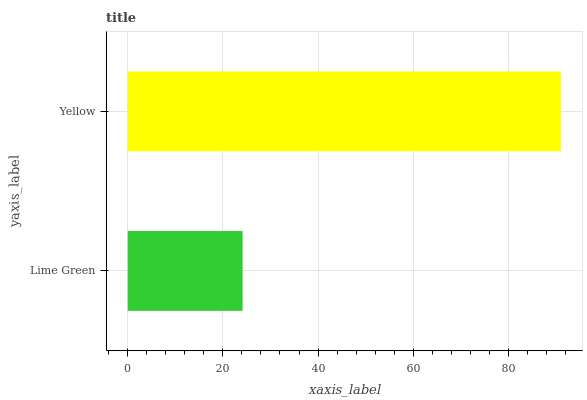Is Lime Green the minimum?
Answer yes or no. Yes. Is Yellow the maximum?
Answer yes or no. Yes. Is Yellow the minimum?
Answer yes or no. No. Is Yellow greater than Lime Green?
Answer yes or no. Yes. Is Lime Green less than Yellow?
Answer yes or no. Yes. Is Lime Green greater than Yellow?
Answer yes or no. No. Is Yellow less than Lime Green?
Answer yes or no. No. Is Yellow the high median?
Answer yes or no. Yes. Is Lime Green the low median?
Answer yes or no. Yes. Is Lime Green the high median?
Answer yes or no. No. Is Yellow the low median?
Answer yes or no. No. 